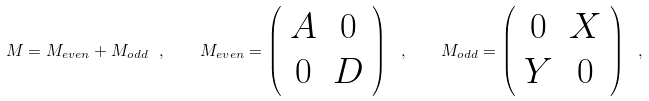<formula> <loc_0><loc_0><loc_500><loc_500>M = M _ { e v e n } + M _ { o d d } \ , \quad M _ { e v e n } = \left ( \begin{array} { c c } A & 0 \\ 0 & D \\ \end{array} \right ) \ , \quad M _ { o d d } = \left ( \begin{array} { c c } 0 & X \\ Y & 0 \\ \end{array} \right ) \ ,</formula> 